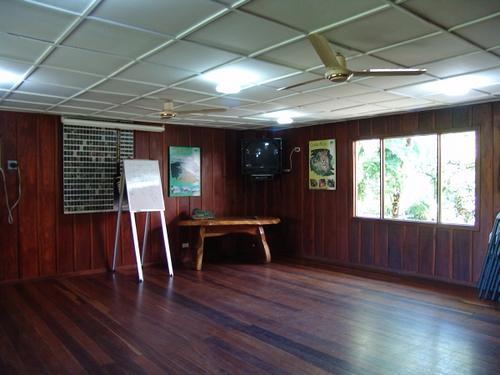How many fans are in the room?
Answer briefly. 2. Are there curtains on the window?
Answer briefly. No. What shape is the table?
Answer briefly. Oval. 